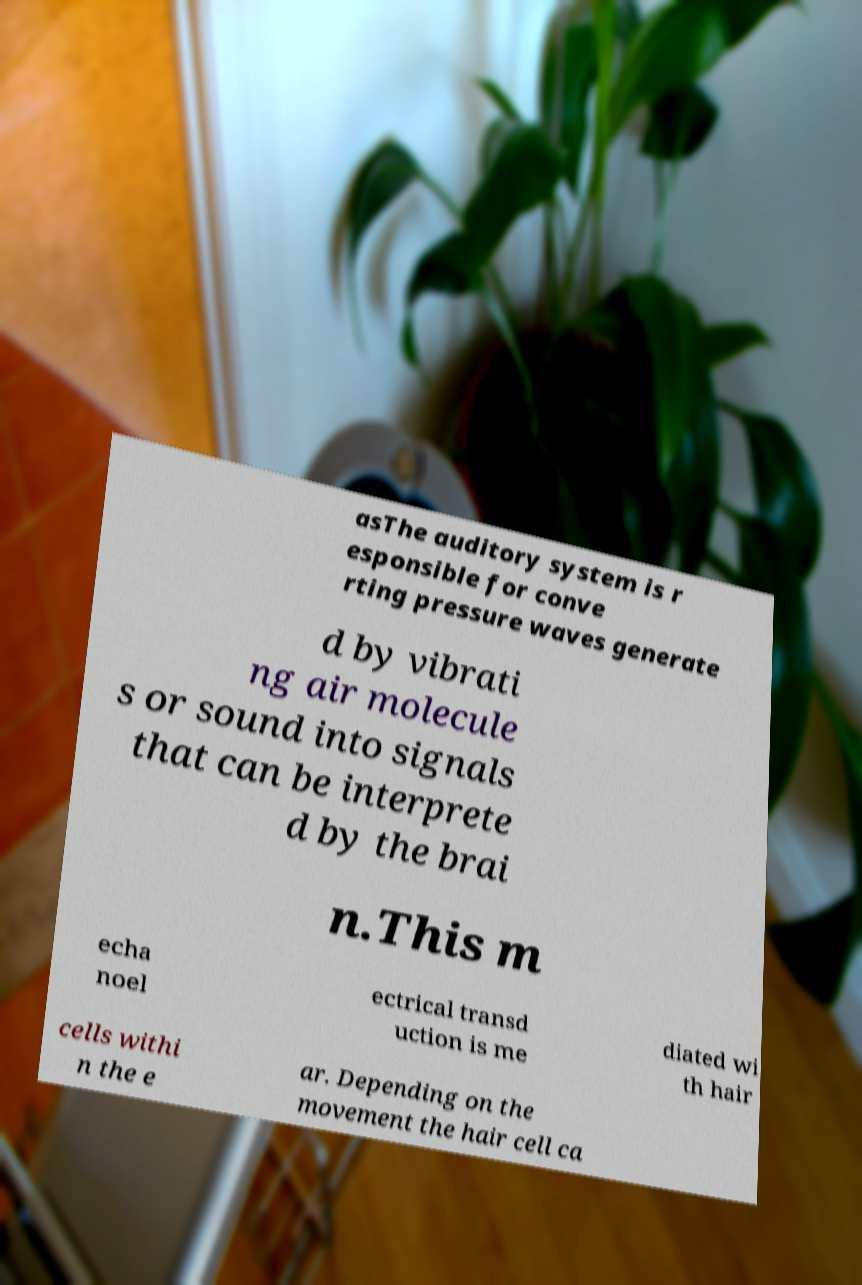I need the written content from this picture converted into text. Can you do that? asThe auditory system is r esponsible for conve rting pressure waves generate d by vibrati ng air molecule s or sound into signals that can be interprete d by the brai n.This m echa noel ectrical transd uction is me diated wi th hair cells withi n the e ar. Depending on the movement the hair cell ca 